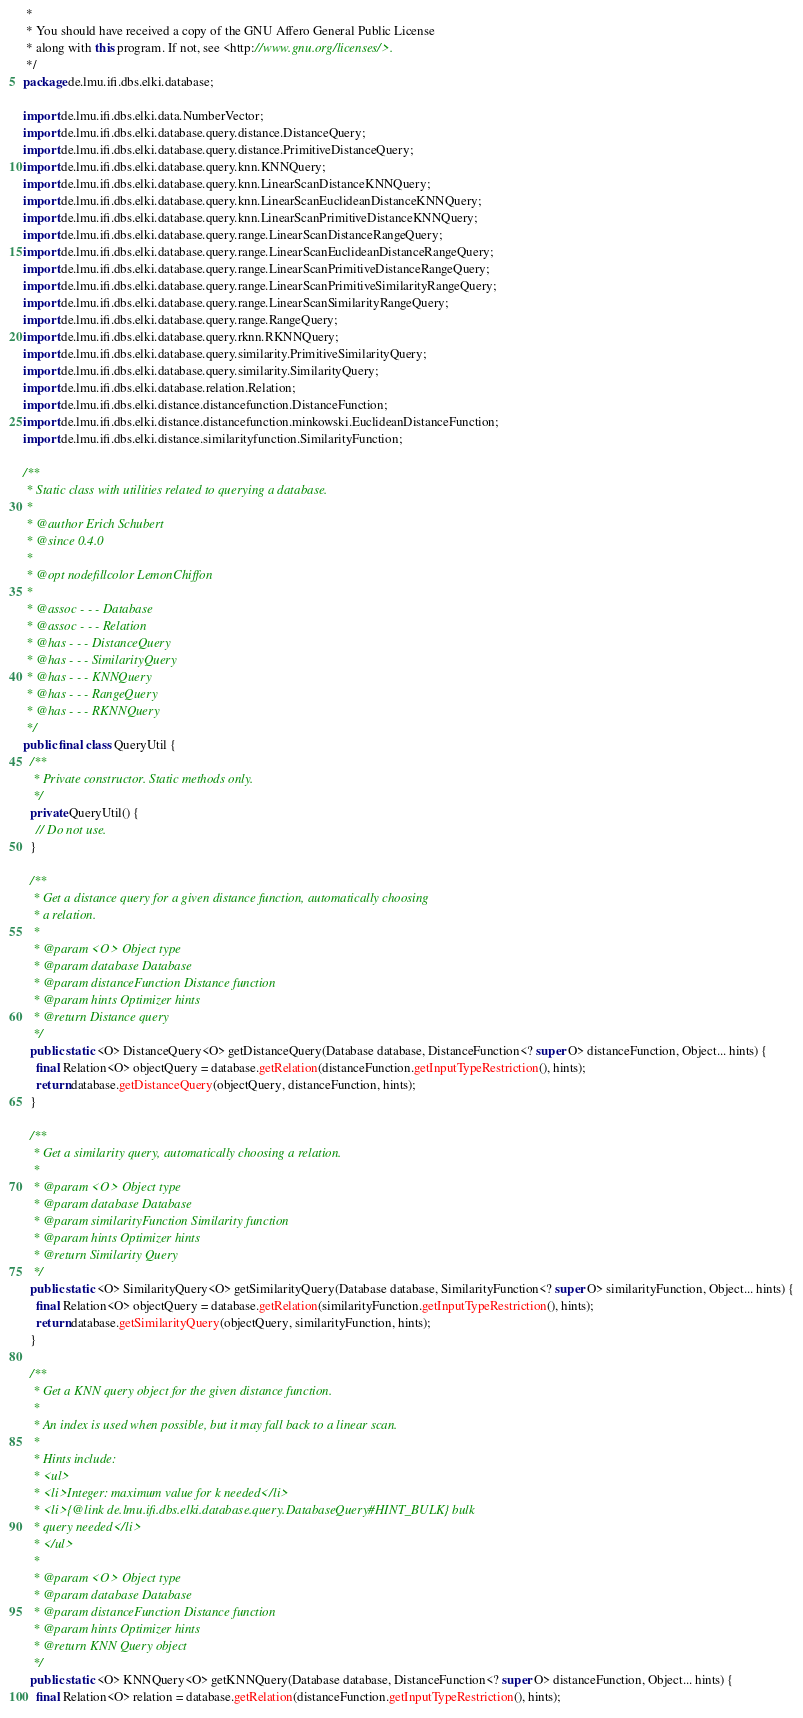Convert code to text. <code><loc_0><loc_0><loc_500><loc_500><_Java_> *
 * You should have received a copy of the GNU Affero General Public License
 * along with this program. If not, see <http://www.gnu.org/licenses/>.
 */
package de.lmu.ifi.dbs.elki.database;

import de.lmu.ifi.dbs.elki.data.NumberVector;
import de.lmu.ifi.dbs.elki.database.query.distance.DistanceQuery;
import de.lmu.ifi.dbs.elki.database.query.distance.PrimitiveDistanceQuery;
import de.lmu.ifi.dbs.elki.database.query.knn.KNNQuery;
import de.lmu.ifi.dbs.elki.database.query.knn.LinearScanDistanceKNNQuery;
import de.lmu.ifi.dbs.elki.database.query.knn.LinearScanEuclideanDistanceKNNQuery;
import de.lmu.ifi.dbs.elki.database.query.knn.LinearScanPrimitiveDistanceKNNQuery;
import de.lmu.ifi.dbs.elki.database.query.range.LinearScanDistanceRangeQuery;
import de.lmu.ifi.dbs.elki.database.query.range.LinearScanEuclideanDistanceRangeQuery;
import de.lmu.ifi.dbs.elki.database.query.range.LinearScanPrimitiveDistanceRangeQuery;
import de.lmu.ifi.dbs.elki.database.query.range.LinearScanPrimitiveSimilarityRangeQuery;
import de.lmu.ifi.dbs.elki.database.query.range.LinearScanSimilarityRangeQuery;
import de.lmu.ifi.dbs.elki.database.query.range.RangeQuery;
import de.lmu.ifi.dbs.elki.database.query.rknn.RKNNQuery;
import de.lmu.ifi.dbs.elki.database.query.similarity.PrimitiveSimilarityQuery;
import de.lmu.ifi.dbs.elki.database.query.similarity.SimilarityQuery;
import de.lmu.ifi.dbs.elki.database.relation.Relation;
import de.lmu.ifi.dbs.elki.distance.distancefunction.DistanceFunction;
import de.lmu.ifi.dbs.elki.distance.distancefunction.minkowski.EuclideanDistanceFunction;
import de.lmu.ifi.dbs.elki.distance.similarityfunction.SimilarityFunction;

/**
 * Static class with utilities related to querying a database.
 *
 * @author Erich Schubert
 * @since 0.4.0
 *
 * @opt nodefillcolor LemonChiffon
 *
 * @assoc - - - Database
 * @assoc - - - Relation
 * @has - - - DistanceQuery
 * @has - - - SimilarityQuery
 * @has - - - KNNQuery
 * @has - - - RangeQuery
 * @has - - - RKNNQuery
 */
public final class QueryUtil {
  /**
   * Private constructor. Static methods only.
   */
  private QueryUtil() {
    // Do not use.
  }

  /**
   * Get a distance query for a given distance function, automatically choosing
   * a relation.
   *
   * @param <O> Object type
   * @param database Database
   * @param distanceFunction Distance function
   * @param hints Optimizer hints
   * @return Distance query
   */
  public static <O> DistanceQuery<O> getDistanceQuery(Database database, DistanceFunction<? super O> distanceFunction, Object... hints) {
    final Relation<O> objectQuery = database.getRelation(distanceFunction.getInputTypeRestriction(), hints);
    return database.getDistanceQuery(objectQuery, distanceFunction, hints);
  }

  /**
   * Get a similarity query, automatically choosing a relation.
   *
   * @param <O> Object type
   * @param database Database
   * @param similarityFunction Similarity function
   * @param hints Optimizer hints
   * @return Similarity Query
   */
  public static <O> SimilarityQuery<O> getSimilarityQuery(Database database, SimilarityFunction<? super O> similarityFunction, Object... hints) {
    final Relation<O> objectQuery = database.getRelation(similarityFunction.getInputTypeRestriction(), hints);
    return database.getSimilarityQuery(objectQuery, similarityFunction, hints);
  }

  /**
   * Get a KNN query object for the given distance function.
   *
   * An index is used when possible, but it may fall back to a linear scan.
   *
   * Hints include:
   * <ul>
   * <li>Integer: maximum value for k needed</li>
   * <li>{@link de.lmu.ifi.dbs.elki.database.query.DatabaseQuery#HINT_BULK} bulk
   * query needed</li>
   * </ul>
   *
   * @param <O> Object type
   * @param database Database
   * @param distanceFunction Distance function
   * @param hints Optimizer hints
   * @return KNN Query object
   */
  public static <O> KNNQuery<O> getKNNQuery(Database database, DistanceFunction<? super O> distanceFunction, Object... hints) {
    final Relation<O> relation = database.getRelation(distanceFunction.getInputTypeRestriction(), hints);</code> 